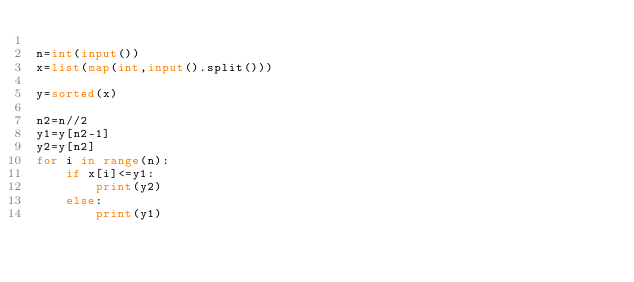Convert code to text. <code><loc_0><loc_0><loc_500><loc_500><_Python_>
n=int(input())
x=list(map(int,input().split()))

y=sorted(x)

n2=n//2
y1=y[n2-1]
y2=y[n2]
for i in range(n):
    if x[i]<=y1:
        print(y2)
    else:
        print(y1)
</code> 